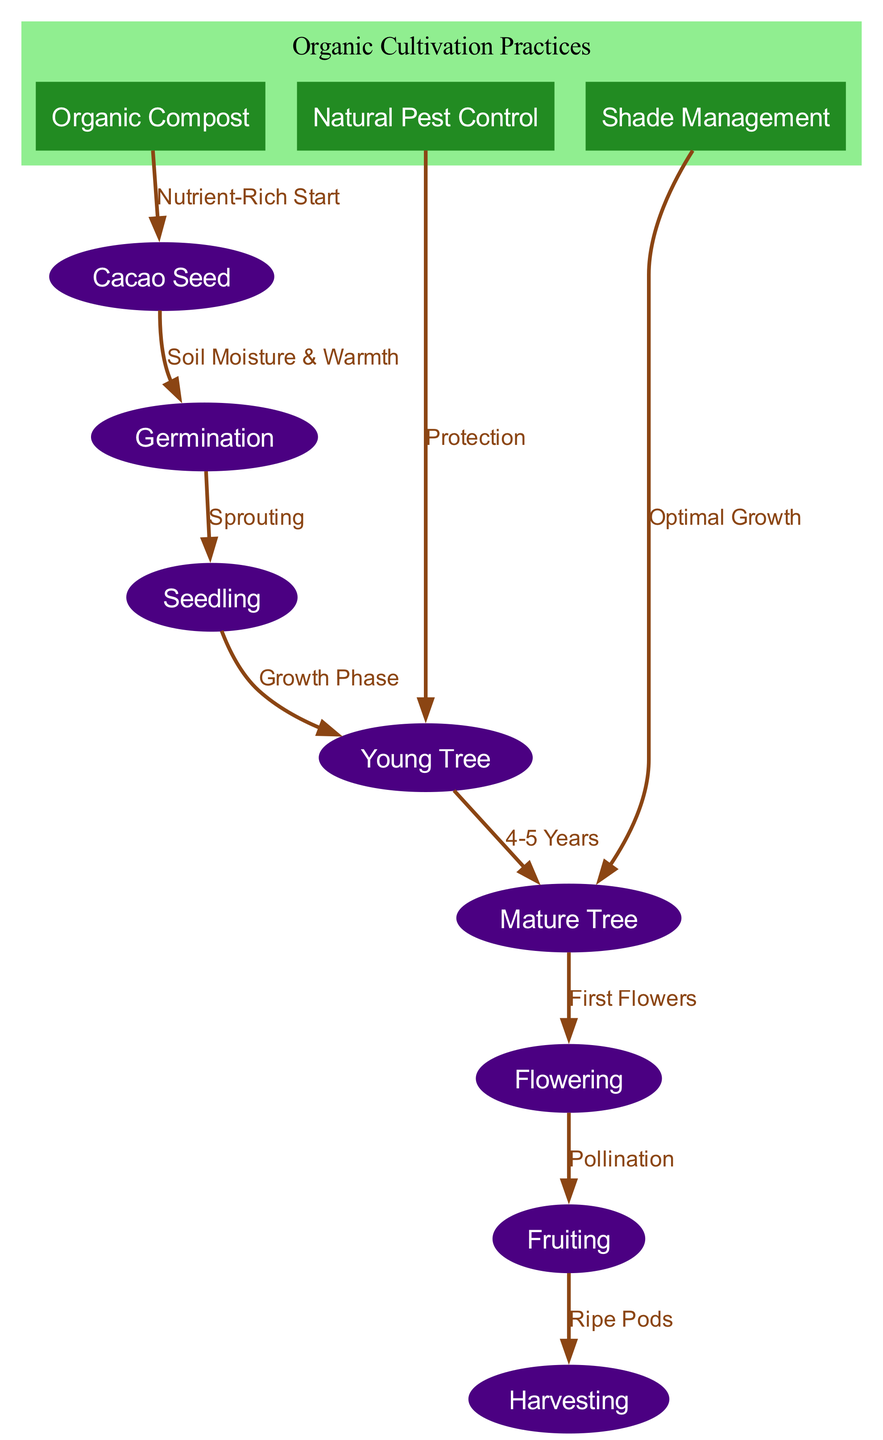What is the first step in the life cycle of a cacao tree? The diagram shows that the first node is "Cacao Seed," indicating that the first step in the life cycle is the seed stage.
Answer: Cacao Seed What labels the transition from Seedling to Young Tree? The edge between the nodes "Seedling" and "Young Tree" is labeled "Growth Phase," representing the process that occurs during this transition.
Answer: Growth Phase How many organic cultivation practices are shown in the diagram? The diagram includes three practices: "Organic Compost," "Natural Pest Control," and "Shade Management," which can be counted by identifying the rectangular nodes.
Answer: 3 What is required for Germination to occur? The arrow from the "Cacao Seed" node to the "Germination" node indicates that "Soil Moisture & Warmth" are necessary conditions for this stage to commence.
Answer: Soil Moisture & Warmth How long does it take for a Young Tree to become a Mature Tree? The diagram shows that it takes "4-5 Years" as labeled on the edge connecting "Young Tree" to "Mature Tree."
Answer: 4-5 Years What happens after the flowering stage? "Pollination" is the descriptive label on the edge leading from the "Flowering" node to the "Fruiting" node, indicating this process occurs after flowering.
Answer: Pollination Which organic practice is connected to the Young Tree? The edge from "Natural Pest Control" to "Young Tree" illustrates that this organic practice is directly linked to safeguarding the Young Tree's growth phase.
Answer: Natural Pest Control Which node represents the final step before harvesting? The "Fruiting" node is positioned right before the "Harvest" node in the diagram, indicating it is the last stage before collecting the produce.
Answer: Fruiting What practice contributes to the initial stage of a cacao tree's life cycle? The edge labeled "Nutrient-Rich Start" connects "Organic Compost" back to "Cacao Seed," indicating that compost enhances the initial growth phase.
Answer: Organic Compost 